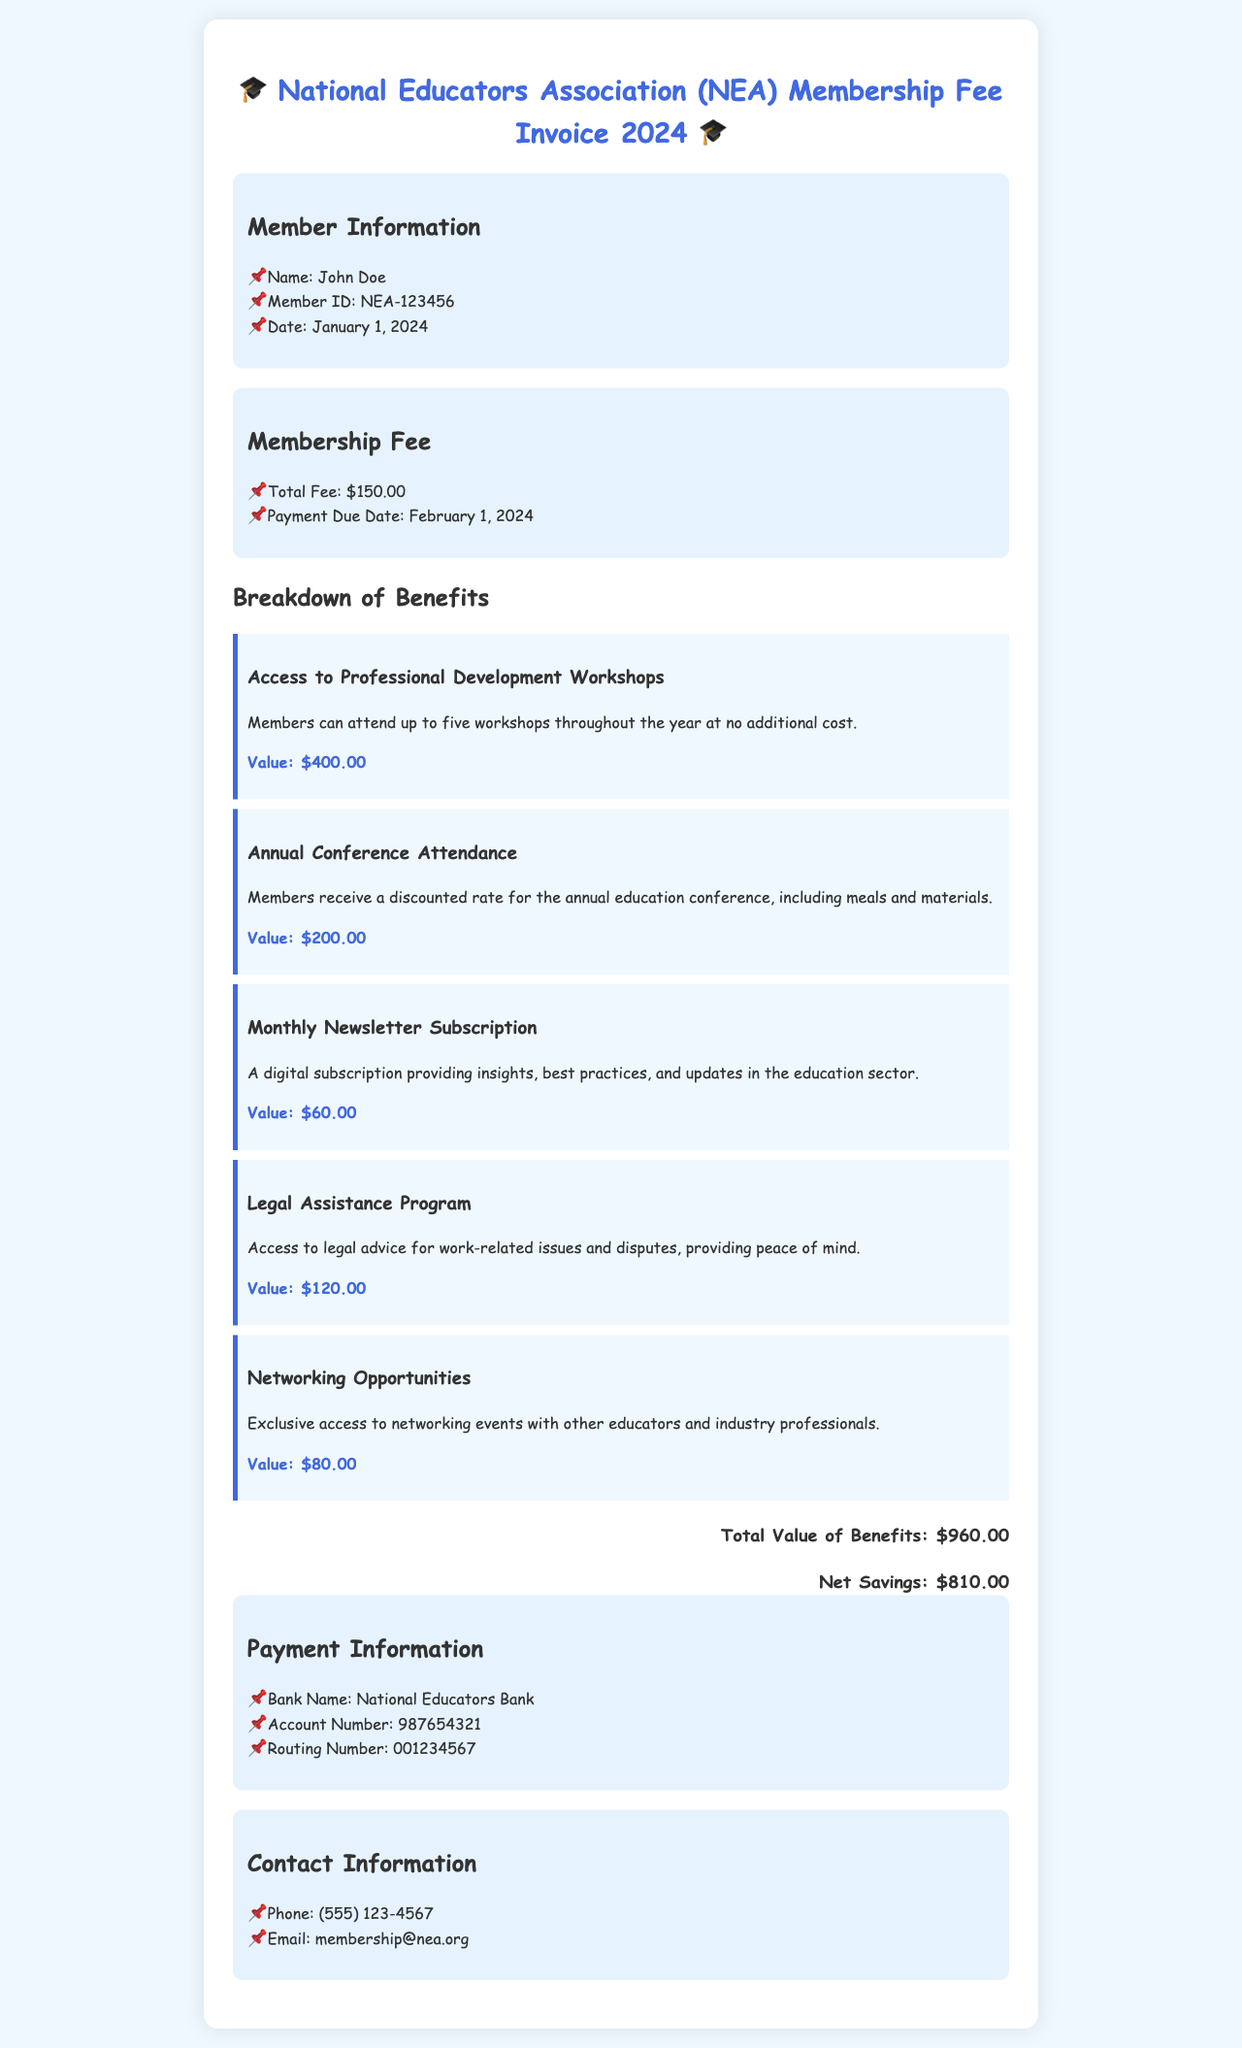What is the member's name? The member's name is explicitly stated in the member information section of the document.
Answer: John Doe What is the membership fee for 2024? The membership fee is mentioned in the fee details section of the invoice.
Answer: $150.00 When is the payment due date? The payment due date is noted in the fee details section as well.
Answer: February 1, 2024 How many workshops can members attend for free? The number of workshops included is mentioned in the benefits section, specifically regarding professional development workshops.
Answer: five What is the total value of benefits? The total value of benefits is summarized at the end of the benefits section in the document.
Answer: $960.00 What is the net savings for the member? The net savings is presented following the total value of benefits in the document.
Answer: $810.00 Is there a legal assistance program included in the membership? The presence of a legal assistance program is specified in the breakdown of benefits, detailing what is included for members.
Answer: Yes What is the email contact for membership inquiries? The email contact for membership is provided in the contact information section.
Answer: membership@nea.org What bank is associated with the membership payments? The bank name is given in the payment information section of the document.
Answer: National Educators Bank 